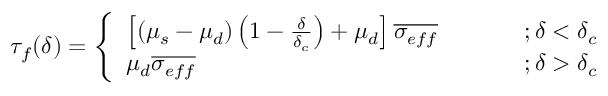Convert formula to latex. <formula><loc_0><loc_0><loc_500><loc_500>\tau _ { f } ( \delta ) = \left \{ \begin{array} { l l } { \left [ ( \mu _ { s } - \mu _ { d } ) \left ( 1 - \frac { \delta } { \delta _ { c } } \right ) + \mu _ { d } \right ] \overline { { \sigma _ { e f f } } } } & { ; \delta < \delta _ { c } } \\ { \mu _ { d } \overline { { \sigma _ { e f f } } } } & { ; \delta > \delta _ { c } } \end{array}</formula> 